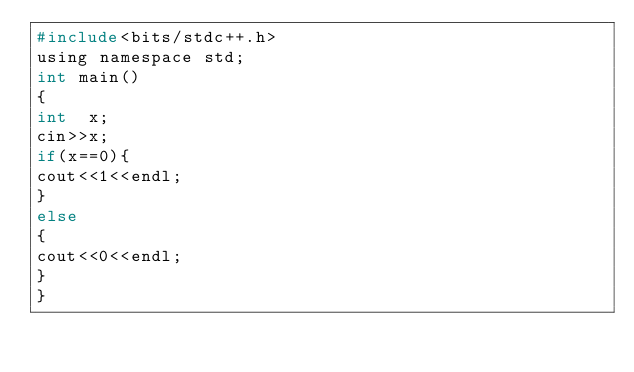Convert code to text. <code><loc_0><loc_0><loc_500><loc_500><_C_>#include<bits/stdc++.h>
using namespace std;
int main()
{
int  x;
cin>>x;
if(x==0){
cout<<1<<endl;
}
else
{
cout<<0<<endl;
}
}</code> 